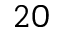<formula> <loc_0><loc_0><loc_500><loc_500>2 0</formula> 